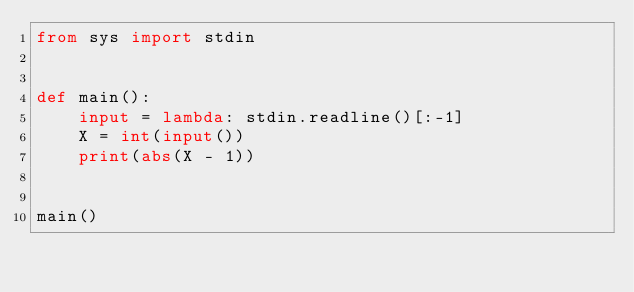<code> <loc_0><loc_0><loc_500><loc_500><_Python_>from sys import stdin


def main():
    input = lambda: stdin.readline()[:-1]
    X = int(input())
    print(abs(X - 1))


main()
</code> 